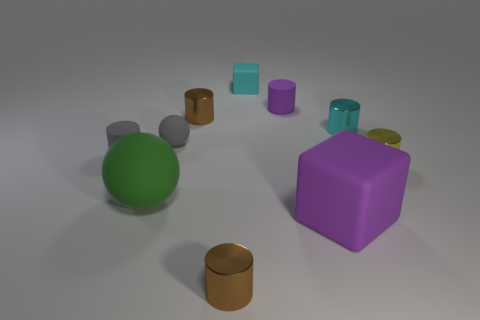Are there any purple matte blocks that are in front of the small brown cylinder in front of the tiny ball?
Your response must be concise. No. What is the color of the other rubber object that is the same shape as the small purple thing?
Ensure brevity in your answer.  Gray. What number of metal objects have the same color as the big cube?
Provide a succinct answer. 0. What color is the rubber block in front of the tiny cyan object that is on the right side of the tiny cyan thing to the left of the small purple object?
Provide a succinct answer. Purple. Is the tiny purple cylinder made of the same material as the cyan block?
Give a very brief answer. Yes. Is the tiny purple thing the same shape as the cyan shiny object?
Offer a very short reply. Yes. Are there the same number of small cyan rubber objects that are to the right of the tiny matte cube and small blocks that are to the left of the gray ball?
Offer a terse response. Yes. There is a large block that is the same material as the big sphere; what color is it?
Keep it short and to the point. Purple. What number of gray spheres are made of the same material as the big green object?
Give a very brief answer. 1. There is a matte sphere in front of the gray rubber sphere; is its color the same as the small sphere?
Provide a succinct answer. No. 